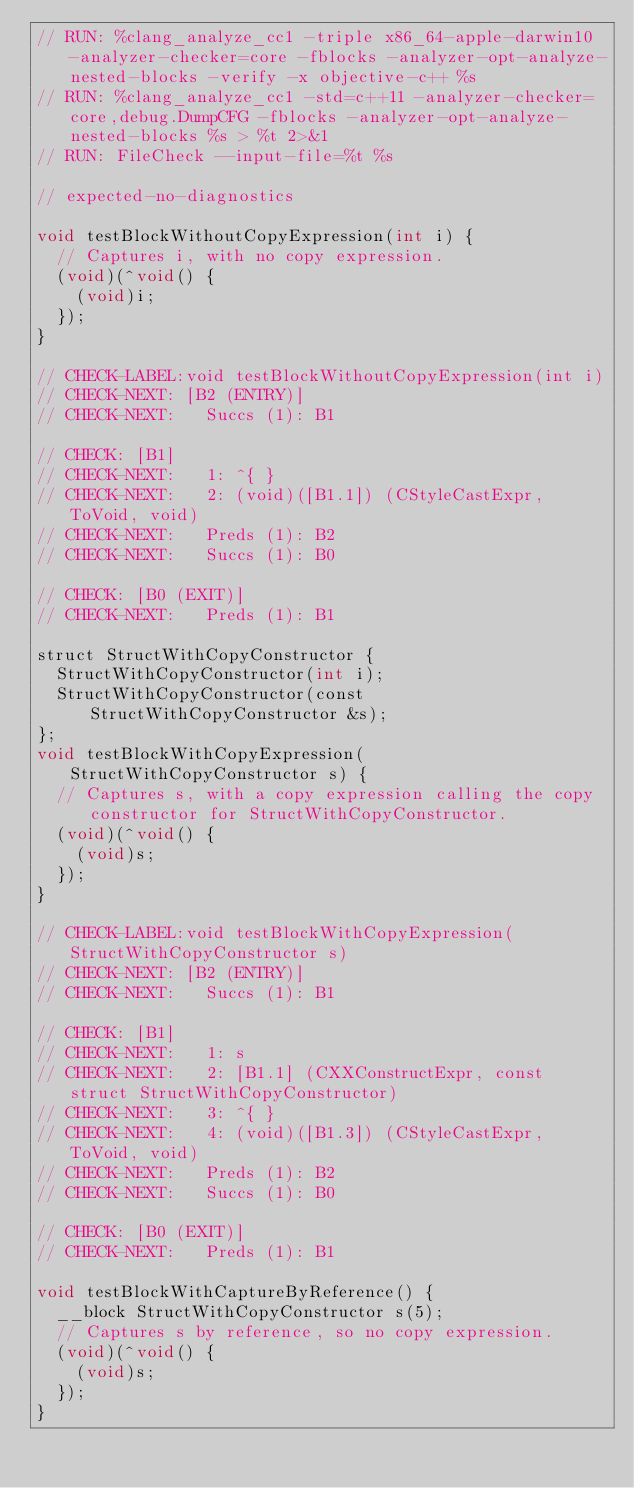<code> <loc_0><loc_0><loc_500><loc_500><_ObjectiveC_>// RUN: %clang_analyze_cc1 -triple x86_64-apple-darwin10 -analyzer-checker=core -fblocks -analyzer-opt-analyze-nested-blocks -verify -x objective-c++ %s
// RUN: %clang_analyze_cc1 -std=c++11 -analyzer-checker=core,debug.DumpCFG -fblocks -analyzer-opt-analyze-nested-blocks %s > %t 2>&1
// RUN: FileCheck --input-file=%t %s

// expected-no-diagnostics

void testBlockWithoutCopyExpression(int i) {
  // Captures i, with no copy expression.
  (void)(^void() {
    (void)i;
  });
}

// CHECK-LABEL:void testBlockWithoutCopyExpression(int i)
// CHECK-NEXT: [B2 (ENTRY)]
// CHECK-NEXT:   Succs (1): B1

// CHECK: [B1]
// CHECK-NEXT:   1: ^{ }
// CHECK-NEXT:   2: (void)([B1.1]) (CStyleCastExpr, ToVoid, void)
// CHECK-NEXT:   Preds (1): B2
// CHECK-NEXT:   Succs (1): B0

// CHECK: [B0 (EXIT)]
// CHECK-NEXT:   Preds (1): B1

struct StructWithCopyConstructor {
  StructWithCopyConstructor(int i);
  StructWithCopyConstructor(const StructWithCopyConstructor &s);
};
void testBlockWithCopyExpression(StructWithCopyConstructor s) {
  // Captures s, with a copy expression calling the copy constructor for StructWithCopyConstructor.
  (void)(^void() {
    (void)s;
  });
}

// CHECK-LABEL:void testBlockWithCopyExpression(StructWithCopyConstructor s)
// CHECK-NEXT: [B2 (ENTRY)]
// CHECK-NEXT:   Succs (1): B1

// CHECK: [B1]
// CHECK-NEXT:   1: s
// CHECK-NEXT:   2: [B1.1] (CXXConstructExpr, const struct StructWithCopyConstructor)
// CHECK-NEXT:   3: ^{ }
// CHECK-NEXT:   4: (void)([B1.3]) (CStyleCastExpr, ToVoid, void)
// CHECK-NEXT:   Preds (1): B2
// CHECK-NEXT:   Succs (1): B0

// CHECK: [B0 (EXIT)]
// CHECK-NEXT:   Preds (1): B1

void testBlockWithCaptureByReference() {
  __block StructWithCopyConstructor s(5);
  // Captures s by reference, so no copy expression.
  (void)(^void() {
    (void)s;
  });
}
</code> 